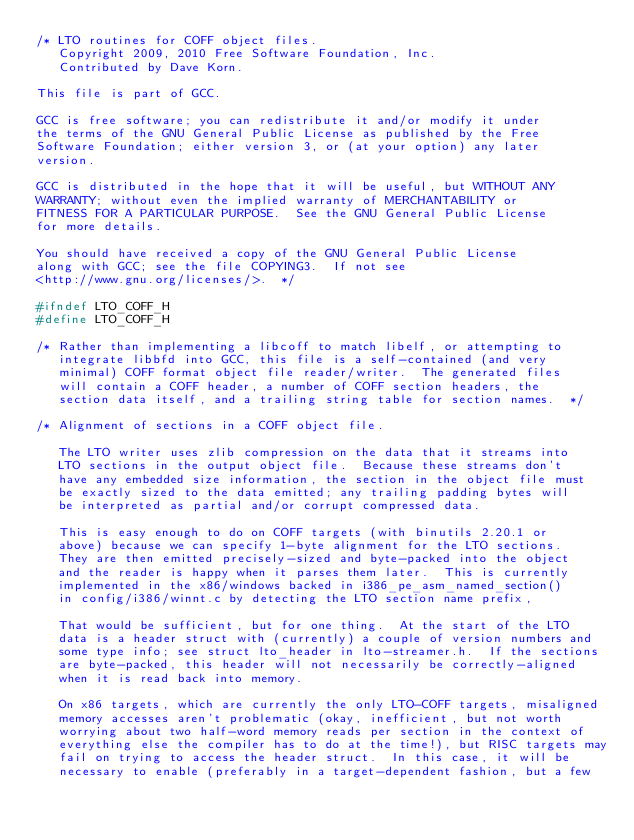Convert code to text. <code><loc_0><loc_0><loc_500><loc_500><_C_>/* LTO routines for COFF object files.
   Copyright 2009, 2010 Free Software Foundation, Inc.
   Contributed by Dave Korn.

This file is part of GCC.

GCC is free software; you can redistribute it and/or modify it under
the terms of the GNU General Public License as published by the Free
Software Foundation; either version 3, or (at your option) any later
version.

GCC is distributed in the hope that it will be useful, but WITHOUT ANY
WARRANTY; without even the implied warranty of MERCHANTABILITY or
FITNESS FOR A PARTICULAR PURPOSE.  See the GNU General Public License
for more details.

You should have received a copy of the GNU General Public License
along with GCC; see the file COPYING3.  If not see
<http://www.gnu.org/licenses/>.  */

#ifndef LTO_COFF_H
#define LTO_COFF_H

/* Rather than implementing a libcoff to match libelf, or attempting to
   integrate libbfd into GCC, this file is a self-contained (and very
   minimal) COFF format object file reader/writer.  The generated files
   will contain a COFF header, a number of COFF section headers, the 
   section data itself, and a trailing string table for section names.  */

/* Alignment of sections in a COFF object file.

   The LTO writer uses zlib compression on the data that it streams into
   LTO sections in the output object file.  Because these streams don't
   have any embedded size information, the section in the object file must
   be exactly sized to the data emitted; any trailing padding bytes will
   be interpreted as partial and/or corrupt compressed data.

   This is easy enough to do on COFF targets (with binutils 2.20.1 or
   above) because we can specify 1-byte alignment for the LTO sections.
   They are then emitted precisely-sized and byte-packed into the object
   and the reader is happy when it parses them later.  This is currently
   implemented in the x86/windows backed in i386_pe_asm_named_section()
   in config/i386/winnt.c by detecting the LTO section name prefix, 

   That would be sufficient, but for one thing.  At the start of the LTO
   data is a header struct with (currently) a couple of version numbers and
   some type info; see struct lto_header in lto-streamer.h.  If the sections
   are byte-packed, this header will not necessarily be correctly-aligned
   when it is read back into memory.

   On x86 targets, which are currently the only LTO-COFF targets, misaligned
   memory accesses aren't problematic (okay, inefficient, but not worth
   worrying about two half-word memory reads per section in the context of
   everything else the compiler has to do at the time!), but RISC targets may
   fail on trying to access the header struct.  In this case, it will be
   necessary to enable (preferably in a target-dependent fashion, but a few</code> 